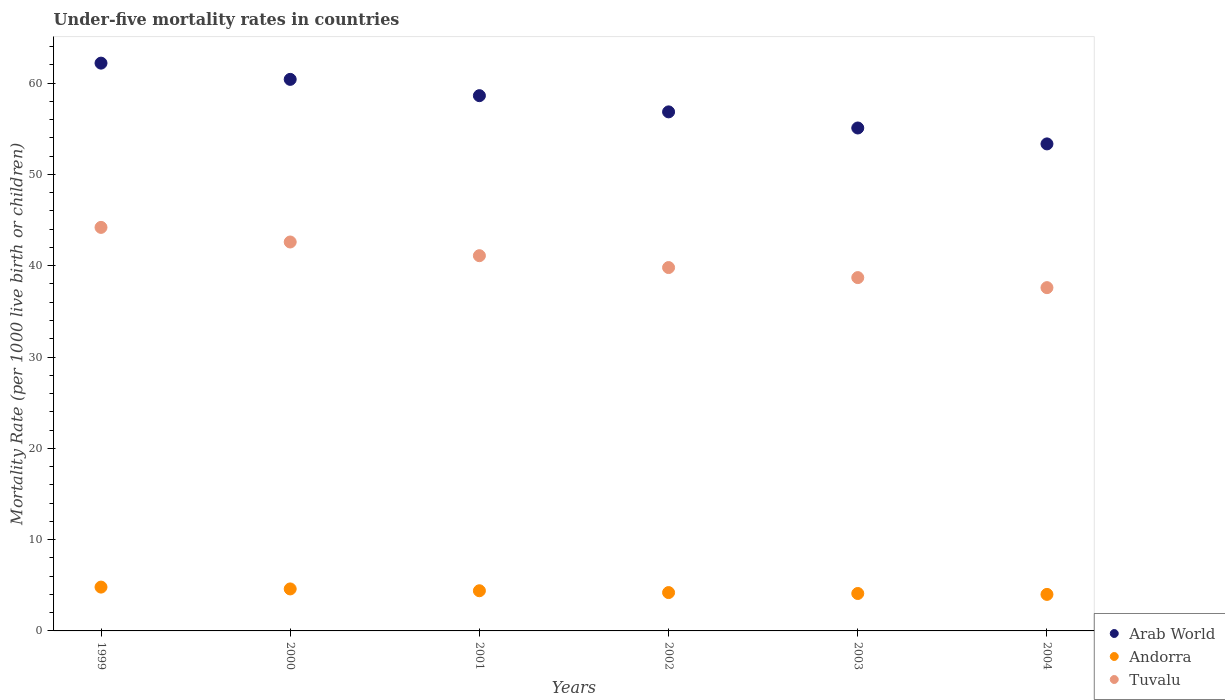How many different coloured dotlines are there?
Provide a succinct answer. 3. Is the number of dotlines equal to the number of legend labels?
Ensure brevity in your answer.  Yes. What is the under-five mortality rate in Arab World in 1999?
Provide a short and direct response. 62.19. Across all years, what is the maximum under-five mortality rate in Andorra?
Offer a very short reply. 4.8. Across all years, what is the minimum under-five mortality rate in Arab World?
Give a very brief answer. 53.34. In which year was the under-five mortality rate in Andorra maximum?
Offer a terse response. 1999. What is the total under-five mortality rate in Andorra in the graph?
Provide a succinct answer. 26.1. What is the difference between the under-five mortality rate in Andorra in 2000 and that in 2004?
Make the answer very short. 0.6. What is the difference between the under-five mortality rate in Arab World in 2004 and the under-five mortality rate in Andorra in 2002?
Keep it short and to the point. 49.14. What is the average under-five mortality rate in Andorra per year?
Provide a short and direct response. 4.35. In the year 2004, what is the difference between the under-five mortality rate in Arab World and under-five mortality rate in Tuvalu?
Provide a short and direct response. 15.74. In how many years, is the under-five mortality rate in Andorra greater than 32?
Offer a very short reply. 0. What is the ratio of the under-five mortality rate in Andorra in 1999 to that in 2000?
Ensure brevity in your answer.  1.04. Is the under-five mortality rate in Andorra in 1999 less than that in 2000?
Offer a very short reply. No. What is the difference between the highest and the second highest under-five mortality rate in Tuvalu?
Provide a succinct answer. 1.6. What is the difference between the highest and the lowest under-five mortality rate in Arab World?
Offer a terse response. 8.85. In how many years, is the under-five mortality rate in Tuvalu greater than the average under-five mortality rate in Tuvalu taken over all years?
Offer a terse response. 3. Does the under-five mortality rate in Andorra monotonically increase over the years?
Make the answer very short. No. Is the under-five mortality rate in Arab World strictly greater than the under-five mortality rate in Andorra over the years?
Offer a very short reply. Yes. Is the under-five mortality rate in Tuvalu strictly less than the under-five mortality rate in Andorra over the years?
Offer a very short reply. No. How many dotlines are there?
Your answer should be compact. 3. How many years are there in the graph?
Provide a succinct answer. 6. What is the difference between two consecutive major ticks on the Y-axis?
Keep it short and to the point. 10. Does the graph contain grids?
Your answer should be very brief. No. Where does the legend appear in the graph?
Keep it short and to the point. Bottom right. How many legend labels are there?
Provide a short and direct response. 3. How are the legend labels stacked?
Offer a terse response. Vertical. What is the title of the graph?
Offer a very short reply. Under-five mortality rates in countries. What is the label or title of the Y-axis?
Provide a succinct answer. Mortality Rate (per 1000 live birth or children). What is the Mortality Rate (per 1000 live birth or children) of Arab World in 1999?
Offer a terse response. 62.19. What is the Mortality Rate (per 1000 live birth or children) of Andorra in 1999?
Give a very brief answer. 4.8. What is the Mortality Rate (per 1000 live birth or children) of Tuvalu in 1999?
Make the answer very short. 44.2. What is the Mortality Rate (per 1000 live birth or children) of Arab World in 2000?
Offer a terse response. 60.41. What is the Mortality Rate (per 1000 live birth or children) of Andorra in 2000?
Offer a very short reply. 4.6. What is the Mortality Rate (per 1000 live birth or children) of Tuvalu in 2000?
Make the answer very short. 42.6. What is the Mortality Rate (per 1000 live birth or children) in Arab World in 2001?
Offer a terse response. 58.63. What is the Mortality Rate (per 1000 live birth or children) in Andorra in 2001?
Offer a very short reply. 4.4. What is the Mortality Rate (per 1000 live birth or children) in Tuvalu in 2001?
Make the answer very short. 41.1. What is the Mortality Rate (per 1000 live birth or children) in Arab World in 2002?
Offer a very short reply. 56.85. What is the Mortality Rate (per 1000 live birth or children) in Tuvalu in 2002?
Make the answer very short. 39.8. What is the Mortality Rate (per 1000 live birth or children) of Arab World in 2003?
Offer a very short reply. 55.09. What is the Mortality Rate (per 1000 live birth or children) of Tuvalu in 2003?
Keep it short and to the point. 38.7. What is the Mortality Rate (per 1000 live birth or children) of Arab World in 2004?
Provide a short and direct response. 53.34. What is the Mortality Rate (per 1000 live birth or children) of Tuvalu in 2004?
Your answer should be compact. 37.6. Across all years, what is the maximum Mortality Rate (per 1000 live birth or children) of Arab World?
Make the answer very short. 62.19. Across all years, what is the maximum Mortality Rate (per 1000 live birth or children) in Andorra?
Ensure brevity in your answer.  4.8. Across all years, what is the maximum Mortality Rate (per 1000 live birth or children) in Tuvalu?
Provide a succinct answer. 44.2. Across all years, what is the minimum Mortality Rate (per 1000 live birth or children) of Arab World?
Offer a very short reply. 53.34. Across all years, what is the minimum Mortality Rate (per 1000 live birth or children) in Andorra?
Your answer should be compact. 4. Across all years, what is the minimum Mortality Rate (per 1000 live birth or children) in Tuvalu?
Your response must be concise. 37.6. What is the total Mortality Rate (per 1000 live birth or children) in Arab World in the graph?
Your response must be concise. 346.52. What is the total Mortality Rate (per 1000 live birth or children) of Andorra in the graph?
Provide a succinct answer. 26.1. What is the total Mortality Rate (per 1000 live birth or children) of Tuvalu in the graph?
Your response must be concise. 244. What is the difference between the Mortality Rate (per 1000 live birth or children) of Arab World in 1999 and that in 2000?
Give a very brief answer. 1.78. What is the difference between the Mortality Rate (per 1000 live birth or children) in Arab World in 1999 and that in 2001?
Keep it short and to the point. 3.56. What is the difference between the Mortality Rate (per 1000 live birth or children) of Andorra in 1999 and that in 2001?
Your answer should be compact. 0.4. What is the difference between the Mortality Rate (per 1000 live birth or children) of Tuvalu in 1999 and that in 2001?
Your answer should be compact. 3.1. What is the difference between the Mortality Rate (per 1000 live birth or children) in Arab World in 1999 and that in 2002?
Give a very brief answer. 5.34. What is the difference between the Mortality Rate (per 1000 live birth or children) of Tuvalu in 1999 and that in 2002?
Your answer should be compact. 4.4. What is the difference between the Mortality Rate (per 1000 live birth or children) in Arab World in 1999 and that in 2003?
Provide a succinct answer. 7.1. What is the difference between the Mortality Rate (per 1000 live birth or children) in Andorra in 1999 and that in 2003?
Your answer should be compact. 0.7. What is the difference between the Mortality Rate (per 1000 live birth or children) in Tuvalu in 1999 and that in 2003?
Make the answer very short. 5.5. What is the difference between the Mortality Rate (per 1000 live birth or children) of Arab World in 1999 and that in 2004?
Your answer should be compact. 8.85. What is the difference between the Mortality Rate (per 1000 live birth or children) of Arab World in 2000 and that in 2001?
Offer a very short reply. 1.79. What is the difference between the Mortality Rate (per 1000 live birth or children) in Andorra in 2000 and that in 2001?
Your answer should be compact. 0.2. What is the difference between the Mortality Rate (per 1000 live birth or children) in Tuvalu in 2000 and that in 2001?
Make the answer very short. 1.5. What is the difference between the Mortality Rate (per 1000 live birth or children) in Arab World in 2000 and that in 2002?
Make the answer very short. 3.56. What is the difference between the Mortality Rate (per 1000 live birth or children) in Tuvalu in 2000 and that in 2002?
Keep it short and to the point. 2.8. What is the difference between the Mortality Rate (per 1000 live birth or children) of Arab World in 2000 and that in 2003?
Your answer should be very brief. 5.33. What is the difference between the Mortality Rate (per 1000 live birth or children) of Tuvalu in 2000 and that in 2003?
Keep it short and to the point. 3.9. What is the difference between the Mortality Rate (per 1000 live birth or children) in Arab World in 2000 and that in 2004?
Make the answer very short. 7.07. What is the difference between the Mortality Rate (per 1000 live birth or children) of Andorra in 2000 and that in 2004?
Provide a succinct answer. 0.6. What is the difference between the Mortality Rate (per 1000 live birth or children) of Arab World in 2001 and that in 2002?
Make the answer very short. 1.78. What is the difference between the Mortality Rate (per 1000 live birth or children) in Arab World in 2001 and that in 2003?
Offer a terse response. 3.54. What is the difference between the Mortality Rate (per 1000 live birth or children) in Andorra in 2001 and that in 2003?
Your response must be concise. 0.3. What is the difference between the Mortality Rate (per 1000 live birth or children) in Tuvalu in 2001 and that in 2003?
Keep it short and to the point. 2.4. What is the difference between the Mortality Rate (per 1000 live birth or children) of Arab World in 2001 and that in 2004?
Ensure brevity in your answer.  5.28. What is the difference between the Mortality Rate (per 1000 live birth or children) of Andorra in 2001 and that in 2004?
Provide a short and direct response. 0.4. What is the difference between the Mortality Rate (per 1000 live birth or children) in Tuvalu in 2001 and that in 2004?
Keep it short and to the point. 3.5. What is the difference between the Mortality Rate (per 1000 live birth or children) of Arab World in 2002 and that in 2003?
Your answer should be very brief. 1.76. What is the difference between the Mortality Rate (per 1000 live birth or children) of Andorra in 2002 and that in 2003?
Offer a very short reply. 0.1. What is the difference between the Mortality Rate (per 1000 live birth or children) of Tuvalu in 2002 and that in 2003?
Provide a short and direct response. 1.1. What is the difference between the Mortality Rate (per 1000 live birth or children) in Arab World in 2002 and that in 2004?
Give a very brief answer. 3.51. What is the difference between the Mortality Rate (per 1000 live birth or children) of Arab World in 2003 and that in 2004?
Ensure brevity in your answer.  1.74. What is the difference between the Mortality Rate (per 1000 live birth or children) in Andorra in 2003 and that in 2004?
Offer a very short reply. 0.1. What is the difference between the Mortality Rate (per 1000 live birth or children) in Tuvalu in 2003 and that in 2004?
Your answer should be very brief. 1.1. What is the difference between the Mortality Rate (per 1000 live birth or children) in Arab World in 1999 and the Mortality Rate (per 1000 live birth or children) in Andorra in 2000?
Your answer should be very brief. 57.59. What is the difference between the Mortality Rate (per 1000 live birth or children) of Arab World in 1999 and the Mortality Rate (per 1000 live birth or children) of Tuvalu in 2000?
Provide a succinct answer. 19.59. What is the difference between the Mortality Rate (per 1000 live birth or children) in Andorra in 1999 and the Mortality Rate (per 1000 live birth or children) in Tuvalu in 2000?
Offer a terse response. -37.8. What is the difference between the Mortality Rate (per 1000 live birth or children) in Arab World in 1999 and the Mortality Rate (per 1000 live birth or children) in Andorra in 2001?
Offer a terse response. 57.79. What is the difference between the Mortality Rate (per 1000 live birth or children) of Arab World in 1999 and the Mortality Rate (per 1000 live birth or children) of Tuvalu in 2001?
Your answer should be compact. 21.09. What is the difference between the Mortality Rate (per 1000 live birth or children) in Andorra in 1999 and the Mortality Rate (per 1000 live birth or children) in Tuvalu in 2001?
Provide a short and direct response. -36.3. What is the difference between the Mortality Rate (per 1000 live birth or children) of Arab World in 1999 and the Mortality Rate (per 1000 live birth or children) of Andorra in 2002?
Ensure brevity in your answer.  57.99. What is the difference between the Mortality Rate (per 1000 live birth or children) in Arab World in 1999 and the Mortality Rate (per 1000 live birth or children) in Tuvalu in 2002?
Your answer should be compact. 22.39. What is the difference between the Mortality Rate (per 1000 live birth or children) in Andorra in 1999 and the Mortality Rate (per 1000 live birth or children) in Tuvalu in 2002?
Provide a short and direct response. -35. What is the difference between the Mortality Rate (per 1000 live birth or children) of Arab World in 1999 and the Mortality Rate (per 1000 live birth or children) of Andorra in 2003?
Give a very brief answer. 58.09. What is the difference between the Mortality Rate (per 1000 live birth or children) in Arab World in 1999 and the Mortality Rate (per 1000 live birth or children) in Tuvalu in 2003?
Give a very brief answer. 23.49. What is the difference between the Mortality Rate (per 1000 live birth or children) of Andorra in 1999 and the Mortality Rate (per 1000 live birth or children) of Tuvalu in 2003?
Keep it short and to the point. -33.9. What is the difference between the Mortality Rate (per 1000 live birth or children) in Arab World in 1999 and the Mortality Rate (per 1000 live birth or children) in Andorra in 2004?
Provide a short and direct response. 58.19. What is the difference between the Mortality Rate (per 1000 live birth or children) of Arab World in 1999 and the Mortality Rate (per 1000 live birth or children) of Tuvalu in 2004?
Your answer should be very brief. 24.59. What is the difference between the Mortality Rate (per 1000 live birth or children) in Andorra in 1999 and the Mortality Rate (per 1000 live birth or children) in Tuvalu in 2004?
Keep it short and to the point. -32.8. What is the difference between the Mortality Rate (per 1000 live birth or children) in Arab World in 2000 and the Mortality Rate (per 1000 live birth or children) in Andorra in 2001?
Offer a terse response. 56.01. What is the difference between the Mortality Rate (per 1000 live birth or children) of Arab World in 2000 and the Mortality Rate (per 1000 live birth or children) of Tuvalu in 2001?
Your answer should be very brief. 19.31. What is the difference between the Mortality Rate (per 1000 live birth or children) of Andorra in 2000 and the Mortality Rate (per 1000 live birth or children) of Tuvalu in 2001?
Provide a short and direct response. -36.5. What is the difference between the Mortality Rate (per 1000 live birth or children) in Arab World in 2000 and the Mortality Rate (per 1000 live birth or children) in Andorra in 2002?
Offer a terse response. 56.21. What is the difference between the Mortality Rate (per 1000 live birth or children) in Arab World in 2000 and the Mortality Rate (per 1000 live birth or children) in Tuvalu in 2002?
Keep it short and to the point. 20.61. What is the difference between the Mortality Rate (per 1000 live birth or children) in Andorra in 2000 and the Mortality Rate (per 1000 live birth or children) in Tuvalu in 2002?
Keep it short and to the point. -35.2. What is the difference between the Mortality Rate (per 1000 live birth or children) of Arab World in 2000 and the Mortality Rate (per 1000 live birth or children) of Andorra in 2003?
Keep it short and to the point. 56.31. What is the difference between the Mortality Rate (per 1000 live birth or children) in Arab World in 2000 and the Mortality Rate (per 1000 live birth or children) in Tuvalu in 2003?
Provide a short and direct response. 21.71. What is the difference between the Mortality Rate (per 1000 live birth or children) in Andorra in 2000 and the Mortality Rate (per 1000 live birth or children) in Tuvalu in 2003?
Offer a terse response. -34.1. What is the difference between the Mortality Rate (per 1000 live birth or children) of Arab World in 2000 and the Mortality Rate (per 1000 live birth or children) of Andorra in 2004?
Make the answer very short. 56.41. What is the difference between the Mortality Rate (per 1000 live birth or children) in Arab World in 2000 and the Mortality Rate (per 1000 live birth or children) in Tuvalu in 2004?
Offer a terse response. 22.81. What is the difference between the Mortality Rate (per 1000 live birth or children) of Andorra in 2000 and the Mortality Rate (per 1000 live birth or children) of Tuvalu in 2004?
Provide a succinct answer. -33. What is the difference between the Mortality Rate (per 1000 live birth or children) of Arab World in 2001 and the Mortality Rate (per 1000 live birth or children) of Andorra in 2002?
Offer a terse response. 54.43. What is the difference between the Mortality Rate (per 1000 live birth or children) of Arab World in 2001 and the Mortality Rate (per 1000 live birth or children) of Tuvalu in 2002?
Give a very brief answer. 18.83. What is the difference between the Mortality Rate (per 1000 live birth or children) in Andorra in 2001 and the Mortality Rate (per 1000 live birth or children) in Tuvalu in 2002?
Ensure brevity in your answer.  -35.4. What is the difference between the Mortality Rate (per 1000 live birth or children) in Arab World in 2001 and the Mortality Rate (per 1000 live birth or children) in Andorra in 2003?
Make the answer very short. 54.53. What is the difference between the Mortality Rate (per 1000 live birth or children) in Arab World in 2001 and the Mortality Rate (per 1000 live birth or children) in Tuvalu in 2003?
Give a very brief answer. 19.93. What is the difference between the Mortality Rate (per 1000 live birth or children) in Andorra in 2001 and the Mortality Rate (per 1000 live birth or children) in Tuvalu in 2003?
Offer a very short reply. -34.3. What is the difference between the Mortality Rate (per 1000 live birth or children) in Arab World in 2001 and the Mortality Rate (per 1000 live birth or children) in Andorra in 2004?
Offer a very short reply. 54.63. What is the difference between the Mortality Rate (per 1000 live birth or children) of Arab World in 2001 and the Mortality Rate (per 1000 live birth or children) of Tuvalu in 2004?
Your answer should be compact. 21.03. What is the difference between the Mortality Rate (per 1000 live birth or children) of Andorra in 2001 and the Mortality Rate (per 1000 live birth or children) of Tuvalu in 2004?
Make the answer very short. -33.2. What is the difference between the Mortality Rate (per 1000 live birth or children) of Arab World in 2002 and the Mortality Rate (per 1000 live birth or children) of Andorra in 2003?
Offer a terse response. 52.75. What is the difference between the Mortality Rate (per 1000 live birth or children) in Arab World in 2002 and the Mortality Rate (per 1000 live birth or children) in Tuvalu in 2003?
Ensure brevity in your answer.  18.15. What is the difference between the Mortality Rate (per 1000 live birth or children) of Andorra in 2002 and the Mortality Rate (per 1000 live birth or children) of Tuvalu in 2003?
Offer a very short reply. -34.5. What is the difference between the Mortality Rate (per 1000 live birth or children) in Arab World in 2002 and the Mortality Rate (per 1000 live birth or children) in Andorra in 2004?
Offer a terse response. 52.85. What is the difference between the Mortality Rate (per 1000 live birth or children) in Arab World in 2002 and the Mortality Rate (per 1000 live birth or children) in Tuvalu in 2004?
Your answer should be very brief. 19.25. What is the difference between the Mortality Rate (per 1000 live birth or children) of Andorra in 2002 and the Mortality Rate (per 1000 live birth or children) of Tuvalu in 2004?
Your answer should be very brief. -33.4. What is the difference between the Mortality Rate (per 1000 live birth or children) of Arab World in 2003 and the Mortality Rate (per 1000 live birth or children) of Andorra in 2004?
Offer a terse response. 51.09. What is the difference between the Mortality Rate (per 1000 live birth or children) of Arab World in 2003 and the Mortality Rate (per 1000 live birth or children) of Tuvalu in 2004?
Your answer should be very brief. 17.49. What is the difference between the Mortality Rate (per 1000 live birth or children) of Andorra in 2003 and the Mortality Rate (per 1000 live birth or children) of Tuvalu in 2004?
Provide a succinct answer. -33.5. What is the average Mortality Rate (per 1000 live birth or children) in Arab World per year?
Your response must be concise. 57.75. What is the average Mortality Rate (per 1000 live birth or children) of Andorra per year?
Make the answer very short. 4.35. What is the average Mortality Rate (per 1000 live birth or children) of Tuvalu per year?
Ensure brevity in your answer.  40.67. In the year 1999, what is the difference between the Mortality Rate (per 1000 live birth or children) of Arab World and Mortality Rate (per 1000 live birth or children) of Andorra?
Your answer should be compact. 57.39. In the year 1999, what is the difference between the Mortality Rate (per 1000 live birth or children) of Arab World and Mortality Rate (per 1000 live birth or children) of Tuvalu?
Your response must be concise. 17.99. In the year 1999, what is the difference between the Mortality Rate (per 1000 live birth or children) of Andorra and Mortality Rate (per 1000 live birth or children) of Tuvalu?
Make the answer very short. -39.4. In the year 2000, what is the difference between the Mortality Rate (per 1000 live birth or children) of Arab World and Mortality Rate (per 1000 live birth or children) of Andorra?
Give a very brief answer. 55.81. In the year 2000, what is the difference between the Mortality Rate (per 1000 live birth or children) in Arab World and Mortality Rate (per 1000 live birth or children) in Tuvalu?
Your response must be concise. 17.81. In the year 2000, what is the difference between the Mortality Rate (per 1000 live birth or children) in Andorra and Mortality Rate (per 1000 live birth or children) in Tuvalu?
Ensure brevity in your answer.  -38. In the year 2001, what is the difference between the Mortality Rate (per 1000 live birth or children) in Arab World and Mortality Rate (per 1000 live birth or children) in Andorra?
Your answer should be compact. 54.23. In the year 2001, what is the difference between the Mortality Rate (per 1000 live birth or children) in Arab World and Mortality Rate (per 1000 live birth or children) in Tuvalu?
Give a very brief answer. 17.53. In the year 2001, what is the difference between the Mortality Rate (per 1000 live birth or children) of Andorra and Mortality Rate (per 1000 live birth or children) of Tuvalu?
Provide a succinct answer. -36.7. In the year 2002, what is the difference between the Mortality Rate (per 1000 live birth or children) of Arab World and Mortality Rate (per 1000 live birth or children) of Andorra?
Keep it short and to the point. 52.65. In the year 2002, what is the difference between the Mortality Rate (per 1000 live birth or children) in Arab World and Mortality Rate (per 1000 live birth or children) in Tuvalu?
Your response must be concise. 17.05. In the year 2002, what is the difference between the Mortality Rate (per 1000 live birth or children) of Andorra and Mortality Rate (per 1000 live birth or children) of Tuvalu?
Keep it short and to the point. -35.6. In the year 2003, what is the difference between the Mortality Rate (per 1000 live birth or children) in Arab World and Mortality Rate (per 1000 live birth or children) in Andorra?
Your answer should be very brief. 50.99. In the year 2003, what is the difference between the Mortality Rate (per 1000 live birth or children) in Arab World and Mortality Rate (per 1000 live birth or children) in Tuvalu?
Provide a short and direct response. 16.39. In the year 2003, what is the difference between the Mortality Rate (per 1000 live birth or children) in Andorra and Mortality Rate (per 1000 live birth or children) in Tuvalu?
Keep it short and to the point. -34.6. In the year 2004, what is the difference between the Mortality Rate (per 1000 live birth or children) in Arab World and Mortality Rate (per 1000 live birth or children) in Andorra?
Your answer should be very brief. 49.34. In the year 2004, what is the difference between the Mortality Rate (per 1000 live birth or children) in Arab World and Mortality Rate (per 1000 live birth or children) in Tuvalu?
Make the answer very short. 15.74. In the year 2004, what is the difference between the Mortality Rate (per 1000 live birth or children) in Andorra and Mortality Rate (per 1000 live birth or children) in Tuvalu?
Your answer should be compact. -33.6. What is the ratio of the Mortality Rate (per 1000 live birth or children) in Arab World in 1999 to that in 2000?
Give a very brief answer. 1.03. What is the ratio of the Mortality Rate (per 1000 live birth or children) of Andorra in 1999 to that in 2000?
Keep it short and to the point. 1.04. What is the ratio of the Mortality Rate (per 1000 live birth or children) in Tuvalu in 1999 to that in 2000?
Offer a very short reply. 1.04. What is the ratio of the Mortality Rate (per 1000 live birth or children) of Arab World in 1999 to that in 2001?
Provide a succinct answer. 1.06. What is the ratio of the Mortality Rate (per 1000 live birth or children) in Tuvalu in 1999 to that in 2001?
Offer a terse response. 1.08. What is the ratio of the Mortality Rate (per 1000 live birth or children) in Arab World in 1999 to that in 2002?
Your answer should be compact. 1.09. What is the ratio of the Mortality Rate (per 1000 live birth or children) of Andorra in 1999 to that in 2002?
Offer a very short reply. 1.14. What is the ratio of the Mortality Rate (per 1000 live birth or children) in Tuvalu in 1999 to that in 2002?
Offer a very short reply. 1.11. What is the ratio of the Mortality Rate (per 1000 live birth or children) of Arab World in 1999 to that in 2003?
Your answer should be very brief. 1.13. What is the ratio of the Mortality Rate (per 1000 live birth or children) of Andorra in 1999 to that in 2003?
Keep it short and to the point. 1.17. What is the ratio of the Mortality Rate (per 1000 live birth or children) in Tuvalu in 1999 to that in 2003?
Your response must be concise. 1.14. What is the ratio of the Mortality Rate (per 1000 live birth or children) of Arab World in 1999 to that in 2004?
Keep it short and to the point. 1.17. What is the ratio of the Mortality Rate (per 1000 live birth or children) in Tuvalu in 1999 to that in 2004?
Your answer should be compact. 1.18. What is the ratio of the Mortality Rate (per 1000 live birth or children) in Arab World in 2000 to that in 2001?
Provide a short and direct response. 1.03. What is the ratio of the Mortality Rate (per 1000 live birth or children) in Andorra in 2000 to that in 2001?
Your answer should be very brief. 1.05. What is the ratio of the Mortality Rate (per 1000 live birth or children) in Tuvalu in 2000 to that in 2001?
Make the answer very short. 1.04. What is the ratio of the Mortality Rate (per 1000 live birth or children) in Arab World in 2000 to that in 2002?
Provide a short and direct response. 1.06. What is the ratio of the Mortality Rate (per 1000 live birth or children) in Andorra in 2000 to that in 2002?
Provide a short and direct response. 1.1. What is the ratio of the Mortality Rate (per 1000 live birth or children) in Tuvalu in 2000 to that in 2002?
Your response must be concise. 1.07. What is the ratio of the Mortality Rate (per 1000 live birth or children) in Arab World in 2000 to that in 2003?
Make the answer very short. 1.1. What is the ratio of the Mortality Rate (per 1000 live birth or children) in Andorra in 2000 to that in 2003?
Your answer should be very brief. 1.12. What is the ratio of the Mortality Rate (per 1000 live birth or children) in Tuvalu in 2000 to that in 2003?
Ensure brevity in your answer.  1.1. What is the ratio of the Mortality Rate (per 1000 live birth or children) of Arab World in 2000 to that in 2004?
Make the answer very short. 1.13. What is the ratio of the Mortality Rate (per 1000 live birth or children) of Andorra in 2000 to that in 2004?
Provide a short and direct response. 1.15. What is the ratio of the Mortality Rate (per 1000 live birth or children) in Tuvalu in 2000 to that in 2004?
Your answer should be compact. 1.13. What is the ratio of the Mortality Rate (per 1000 live birth or children) of Arab World in 2001 to that in 2002?
Provide a succinct answer. 1.03. What is the ratio of the Mortality Rate (per 1000 live birth or children) in Andorra in 2001 to that in 2002?
Your answer should be compact. 1.05. What is the ratio of the Mortality Rate (per 1000 live birth or children) in Tuvalu in 2001 to that in 2002?
Keep it short and to the point. 1.03. What is the ratio of the Mortality Rate (per 1000 live birth or children) in Arab World in 2001 to that in 2003?
Make the answer very short. 1.06. What is the ratio of the Mortality Rate (per 1000 live birth or children) of Andorra in 2001 to that in 2003?
Offer a very short reply. 1.07. What is the ratio of the Mortality Rate (per 1000 live birth or children) in Tuvalu in 2001 to that in 2003?
Give a very brief answer. 1.06. What is the ratio of the Mortality Rate (per 1000 live birth or children) of Arab World in 2001 to that in 2004?
Your answer should be very brief. 1.1. What is the ratio of the Mortality Rate (per 1000 live birth or children) of Tuvalu in 2001 to that in 2004?
Provide a succinct answer. 1.09. What is the ratio of the Mortality Rate (per 1000 live birth or children) in Arab World in 2002 to that in 2003?
Give a very brief answer. 1.03. What is the ratio of the Mortality Rate (per 1000 live birth or children) of Andorra in 2002 to that in 2003?
Provide a succinct answer. 1.02. What is the ratio of the Mortality Rate (per 1000 live birth or children) of Tuvalu in 2002 to that in 2003?
Offer a terse response. 1.03. What is the ratio of the Mortality Rate (per 1000 live birth or children) of Arab World in 2002 to that in 2004?
Your answer should be compact. 1.07. What is the ratio of the Mortality Rate (per 1000 live birth or children) in Andorra in 2002 to that in 2004?
Offer a terse response. 1.05. What is the ratio of the Mortality Rate (per 1000 live birth or children) in Tuvalu in 2002 to that in 2004?
Offer a very short reply. 1.06. What is the ratio of the Mortality Rate (per 1000 live birth or children) of Arab World in 2003 to that in 2004?
Provide a succinct answer. 1.03. What is the ratio of the Mortality Rate (per 1000 live birth or children) in Andorra in 2003 to that in 2004?
Your answer should be compact. 1.02. What is the ratio of the Mortality Rate (per 1000 live birth or children) in Tuvalu in 2003 to that in 2004?
Ensure brevity in your answer.  1.03. What is the difference between the highest and the second highest Mortality Rate (per 1000 live birth or children) of Arab World?
Give a very brief answer. 1.78. What is the difference between the highest and the second highest Mortality Rate (per 1000 live birth or children) of Andorra?
Your answer should be very brief. 0.2. What is the difference between the highest and the lowest Mortality Rate (per 1000 live birth or children) of Arab World?
Keep it short and to the point. 8.85. What is the difference between the highest and the lowest Mortality Rate (per 1000 live birth or children) of Andorra?
Make the answer very short. 0.8. 